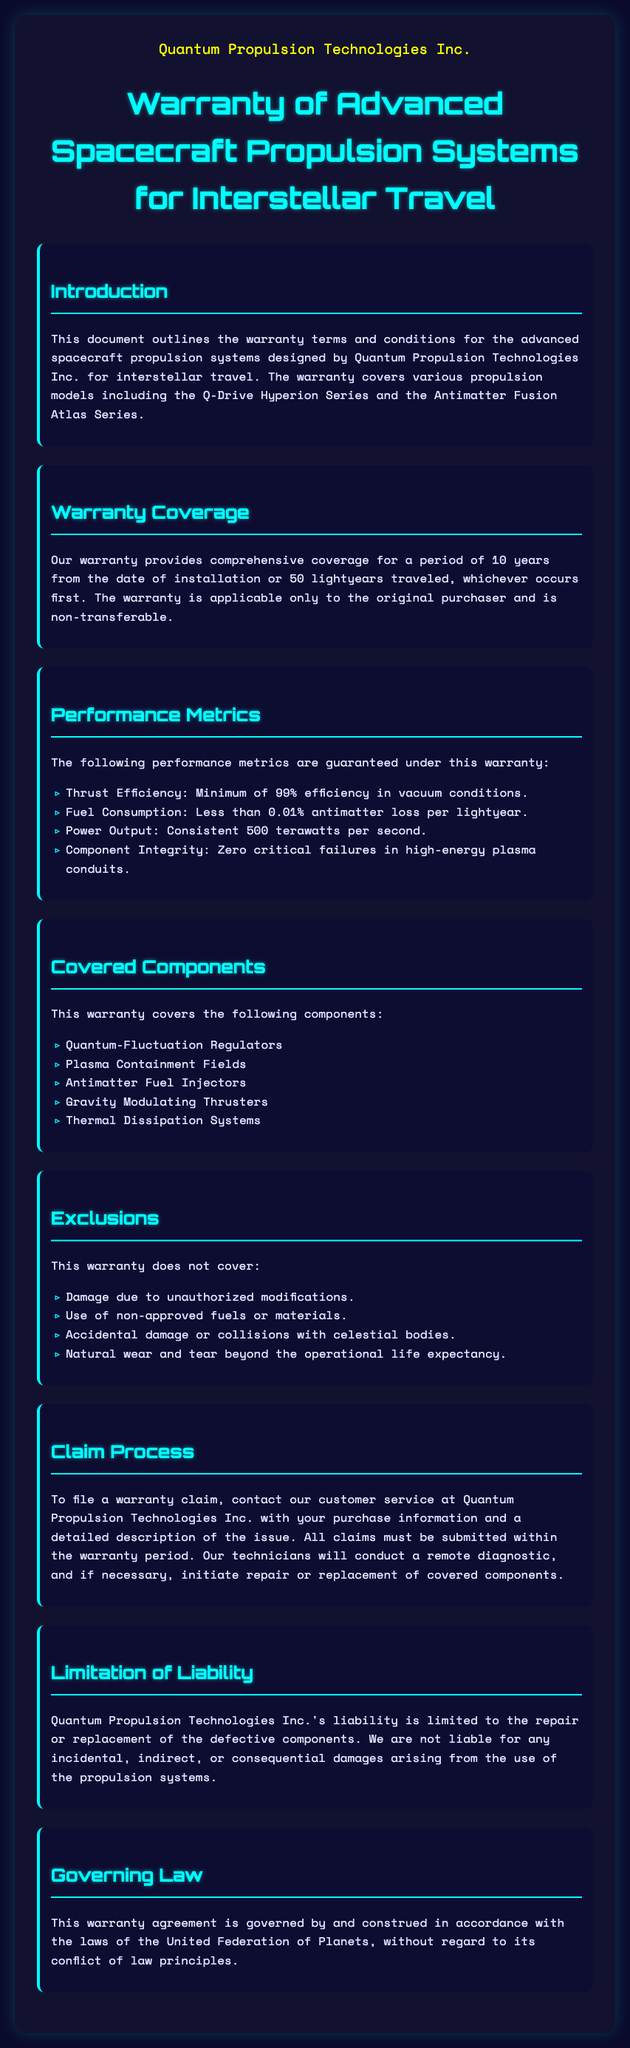What is the company name? The company name is stated prominently at the beginning of the document, which is Quantum Propulsion Technologies Inc.
Answer: Quantum Propulsion Technologies Inc What is the warranty period? The warranty period is defined in the document as 10 years from the date of installation or 50 lightyears traveled, whichever occurs first.
Answer: 10 years What is the minimum thrust efficiency guaranteed? The performance metrics section guarantees a minimum of 99% efficiency in vacuum conditions.
Answer: 99% Which component is excluded from the warranty? The document lists exclusions, and one of those exclusions is damage due to unauthorized modifications.
Answer: Unauthorized modifications How many components are covered under the warranty? The covered components section lists five specific components under the warranty.
Answer: Five What must be submitted for a warranty claim? The document states that purchase information and a detailed description of the issue must be submitted with the warranty claim.
Answer: Purchase information and description What law governs this warranty? The governing law section specifies that the warranty is governed by the laws of the United Federation of Planets.
Answer: United Federation of Planets What is the power output guaranteed under the warranty? The performance metrics list the guaranteed power output as a consistent 500 terawatts per second.
Answer: 500 terawatts per second 